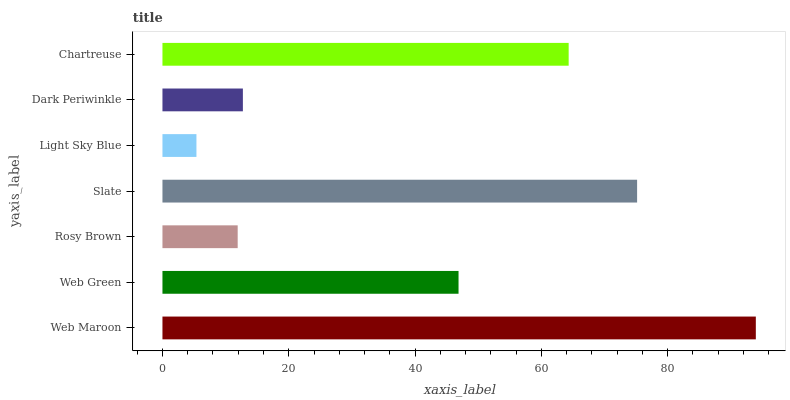Is Light Sky Blue the minimum?
Answer yes or no. Yes. Is Web Maroon the maximum?
Answer yes or no. Yes. Is Web Green the minimum?
Answer yes or no. No. Is Web Green the maximum?
Answer yes or no. No. Is Web Maroon greater than Web Green?
Answer yes or no. Yes. Is Web Green less than Web Maroon?
Answer yes or no. Yes. Is Web Green greater than Web Maroon?
Answer yes or no. No. Is Web Maroon less than Web Green?
Answer yes or no. No. Is Web Green the high median?
Answer yes or no. Yes. Is Web Green the low median?
Answer yes or no. Yes. Is Rosy Brown the high median?
Answer yes or no. No. Is Web Maroon the low median?
Answer yes or no. No. 